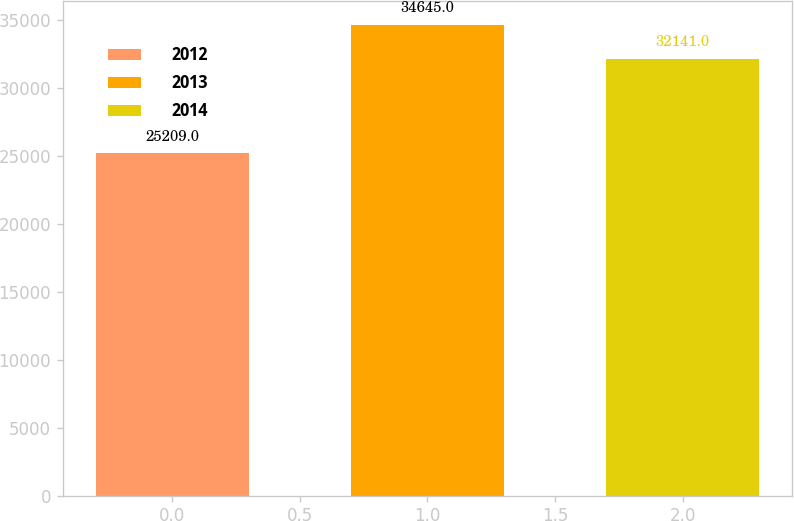Convert chart to OTSL. <chart><loc_0><loc_0><loc_500><loc_500><bar_chart><fcel>2012<fcel>2013<fcel>2014<nl><fcel>25209<fcel>34645<fcel>32141<nl></chart> 